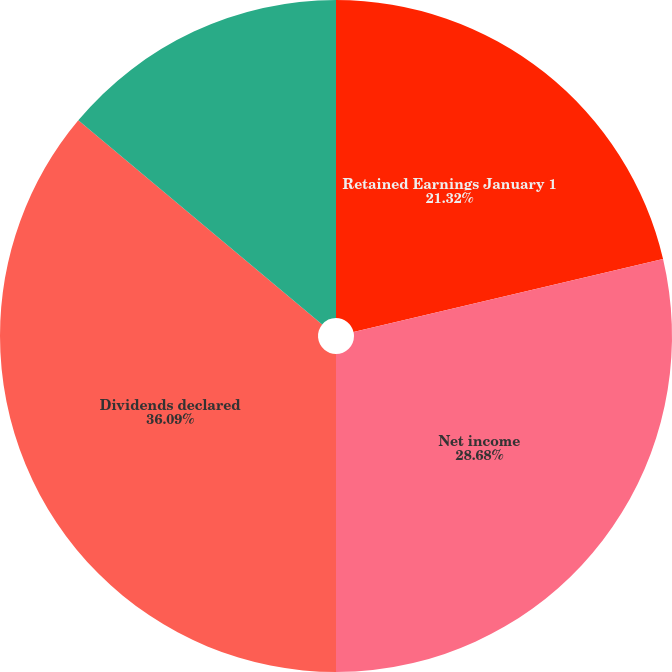<chart> <loc_0><loc_0><loc_500><loc_500><pie_chart><fcel>Retained Earnings January 1<fcel>Net income<fcel>Dividends declared<fcel>Retained Earnings December 31<nl><fcel>21.32%<fcel>28.68%<fcel>36.09%<fcel>13.91%<nl></chart> 